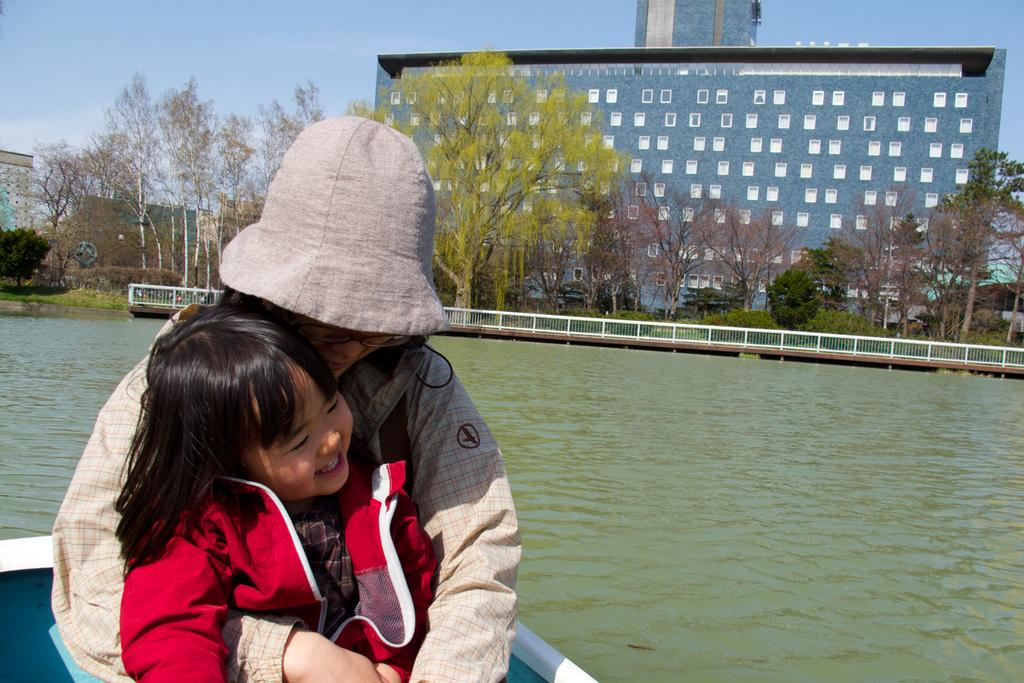How many people are on the boat in the image? There are two people on the boat in the image. What is visible behind the people on the boat? There is water visible behind the people. What can be seen in the background of the image? There is a fence, trees, and buildings in the background. What is visible behind the buildings in the image? The sky is visible behind the buildings. What rule does the minister enforce in the image? There is no minister or rule present in the image. What thing is being used by the people on the boat to float on the water? The image does not specify what the people on the boat are using to float on the water, but it is likely a boat. 